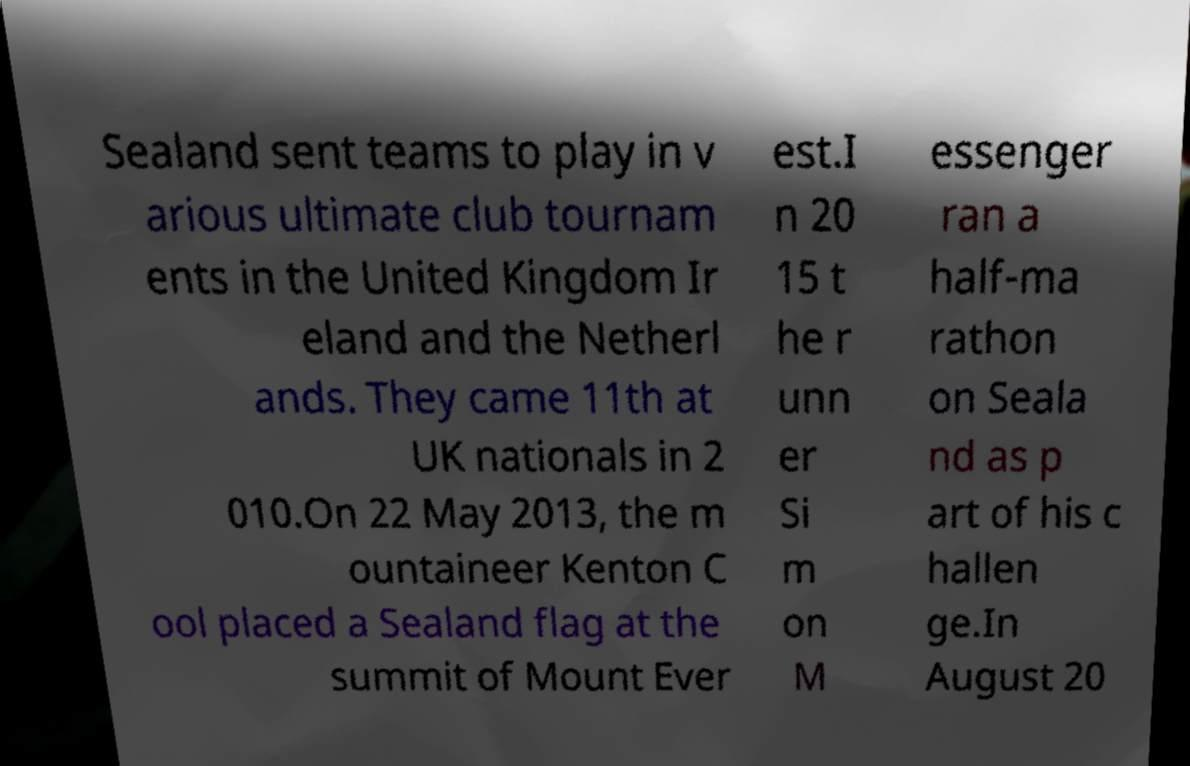Please read and relay the text visible in this image. What does it say? Sealand sent teams to play in v arious ultimate club tournam ents in the United Kingdom Ir eland and the Netherl ands. They came 11th at UK nationals in 2 010.On 22 May 2013, the m ountaineer Kenton C ool placed a Sealand flag at the summit of Mount Ever est.I n 20 15 t he r unn er Si m on M essenger ran a half-ma rathon on Seala nd as p art of his c hallen ge.In August 20 